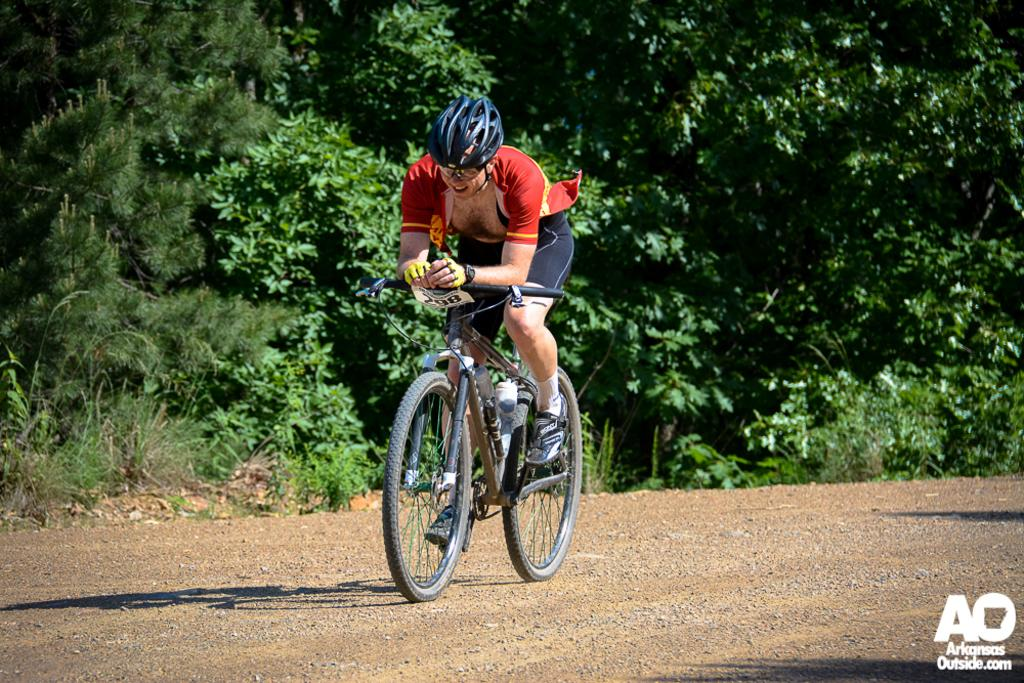What is the main subject of the image? There is a person riding a bicycle in the image. What can be seen in the background of the image? There are plants and trees in the image. What type of flag is being used to cover the sink in the image? There is no flag or sink present in the image. 